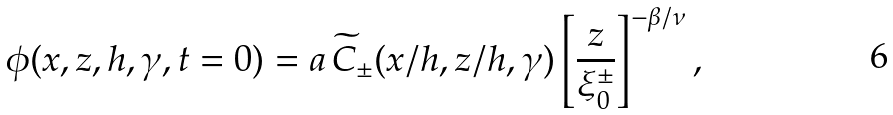Convert formula to latex. <formula><loc_0><loc_0><loc_500><loc_500>\phi ( x , z , h , \gamma , t = 0 ) = a \, \widetilde { C } _ { \pm } ( x / h , z / h , \gamma ) \left [ \frac { z } { \xi _ { 0 } ^ { \pm } } \right ] ^ { - \beta / \nu } ,</formula> 